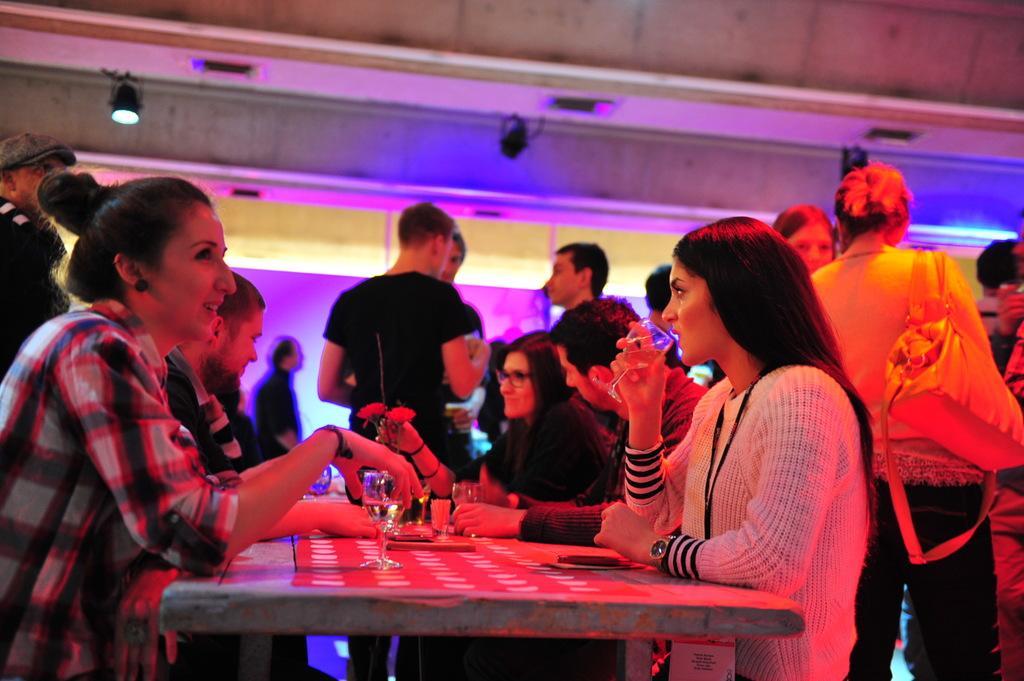Could you give a brief overview of what you see in this image? In this picture there are some people sitting around the table on which there are some glasses. 